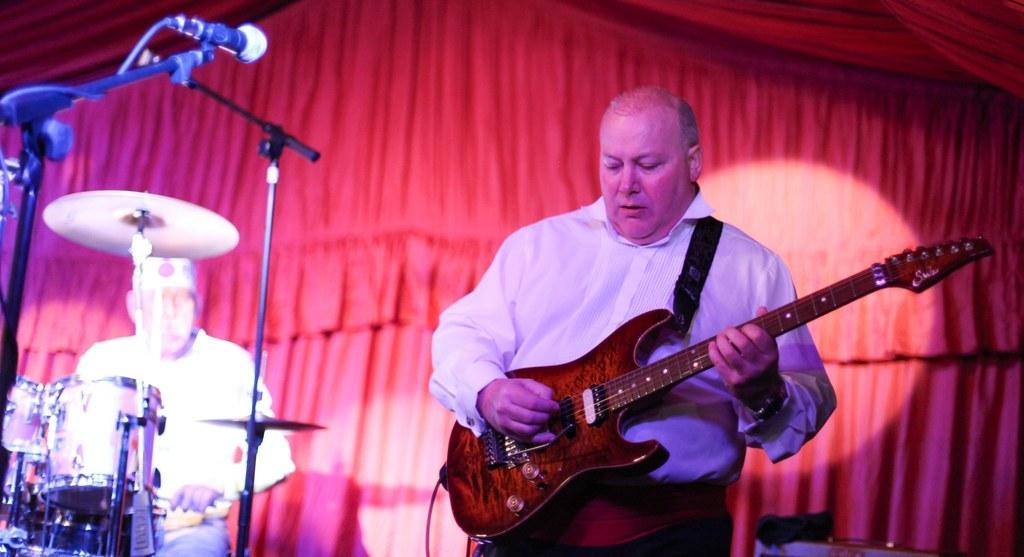Can you describe this image briefly? In this image i can see a person in white shirt is standing and holding a guitar,I can see a microphone in front of him. In the background i can see a person in front of few musical instruments and the curtain. 